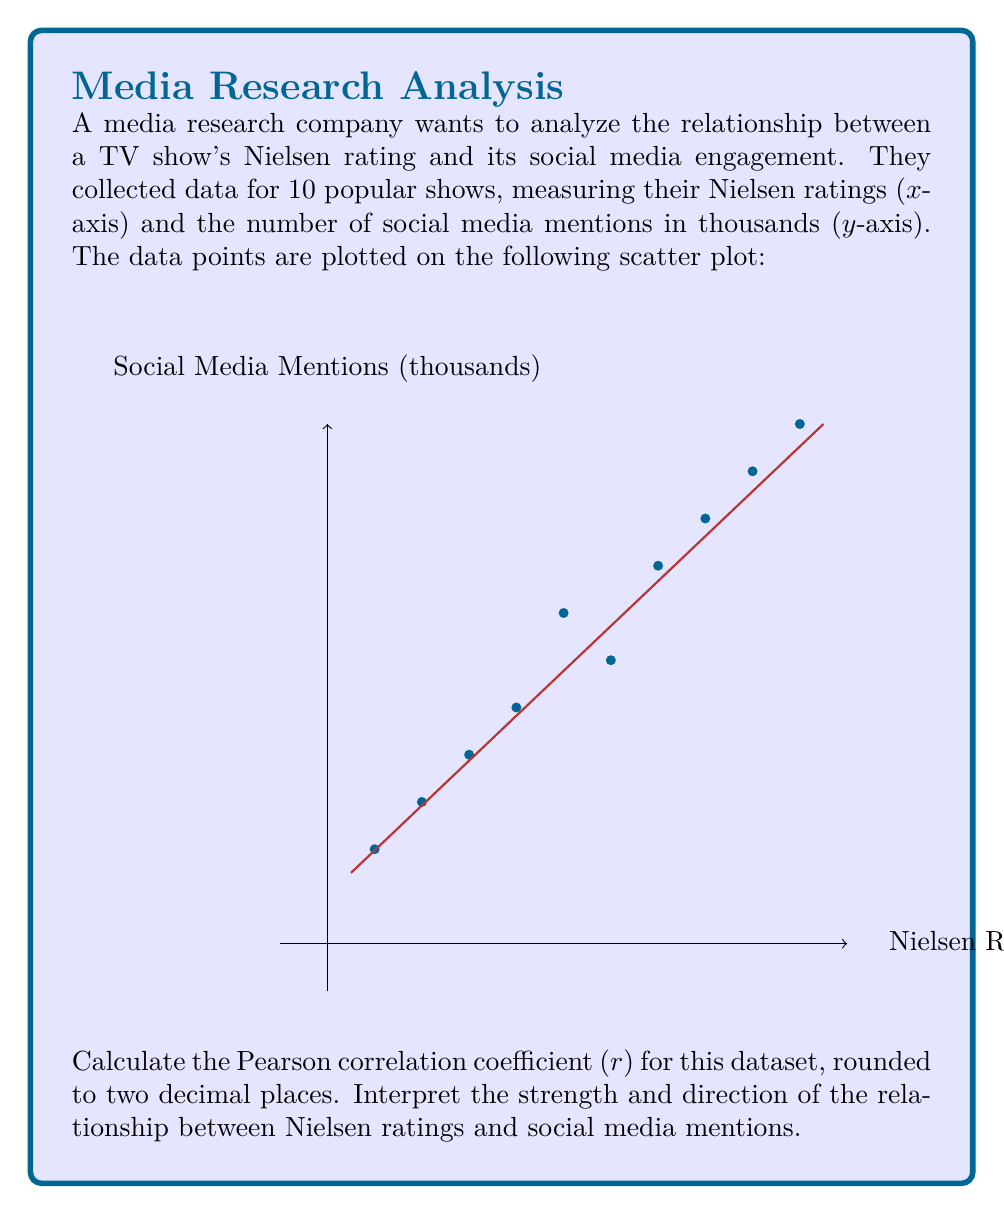Provide a solution to this math problem. To calculate the Pearson correlation coefficient (r), we'll follow these steps:

1) First, we need to calculate the means of x (Nielsen ratings) and y (social media mentions):

   $\bar{x} = \frac{1 + 2 + 3 + 4 + 5 + 6 + 7 + 8 + 9 + 10}{10} = 5.5$
   $\bar{y} = \frac{2 + 3 + 4 + 5 + 7 + 6 + 8 + 9 + 10 + 11}{10} = 6.5$

2) Next, we calculate the numerator of the correlation coefficient formula:

   $\sum_{i=1}^{n} (x_i - \bar{x})(y_i - \bar{y})$

3) Then, we calculate the denominators:

   $\sqrt{\sum_{i=1}^{n} (x_i - \bar{x})^2}$ and $\sqrt{\sum_{i=1}^{n} (y_i - \bar{y})^2}$

4) The formula for the Pearson correlation coefficient is:

   $$r = \frac{\sum_{i=1}^{n} (x_i - \bar{x})(y_i - \bar{y})}{\sqrt{\sum_{i=1}^{n} (x_i - \bar{x})^2} \sqrt{\sum_{i=1}^{n} (y_i - \bar{y})^2}}$$

5) Calculating these values:

   $\sum_{i=1}^{n} (x_i - \bar{x})(y_i - \bar{y}) = 82.5$
   $\sum_{i=1}^{n} (x_i - \bar{x})^2 = 82.5$
   $\sum_{i=1}^{n} (y_i - \bar{y})^2 = 88.5$

6) Plugging these values into the formula:

   $$r = \frac{82.5}{\sqrt{82.5} \sqrt{88.5}} \approx 0.9604$$

7) Rounding to two decimal places: r = 0.96

Interpretation: The correlation coefficient of 0.96 indicates a very strong positive relationship between Nielsen ratings and social media mentions. As Nielsen ratings increase, social media mentions tend to increase as well. The relationship is nearly linear, as the coefficient is very close to 1.
Answer: r = 0.96; very strong positive correlation 